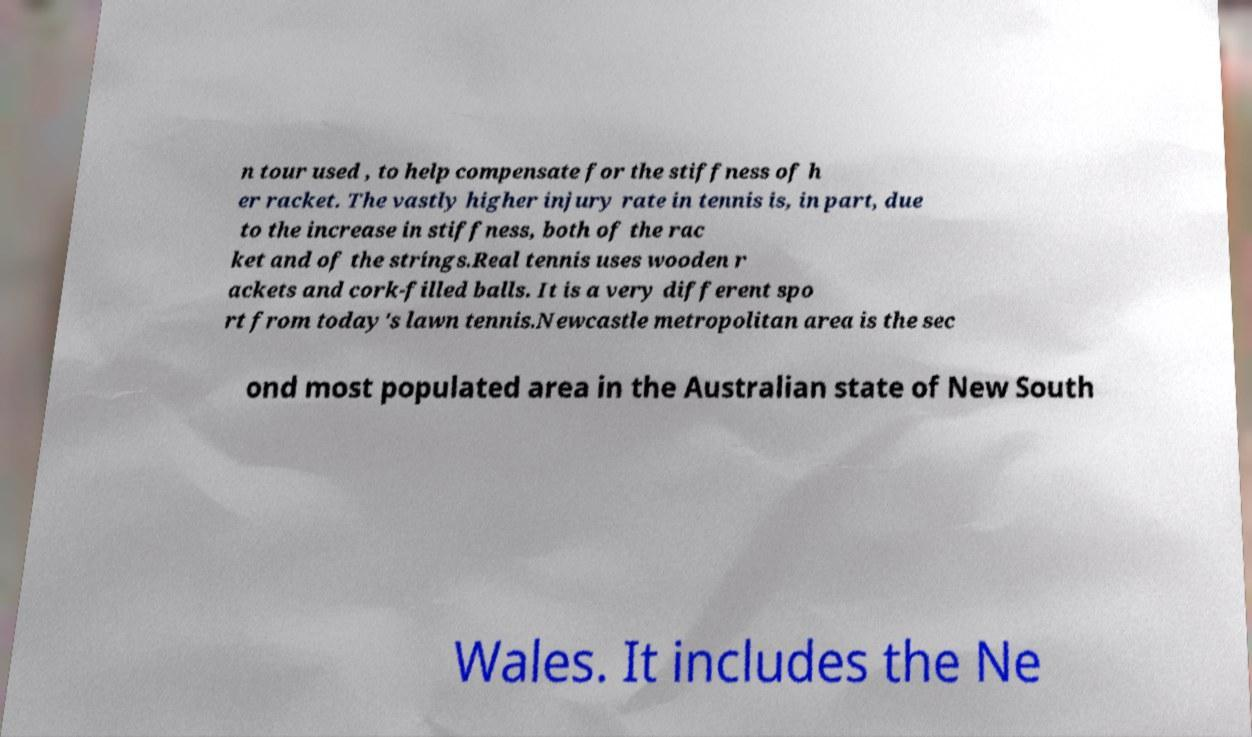Could you extract and type out the text from this image? n tour used , to help compensate for the stiffness of h er racket. The vastly higher injury rate in tennis is, in part, due to the increase in stiffness, both of the rac ket and of the strings.Real tennis uses wooden r ackets and cork-filled balls. It is a very different spo rt from today's lawn tennis.Newcastle metropolitan area is the sec ond most populated area in the Australian state of New South Wales. It includes the Ne 